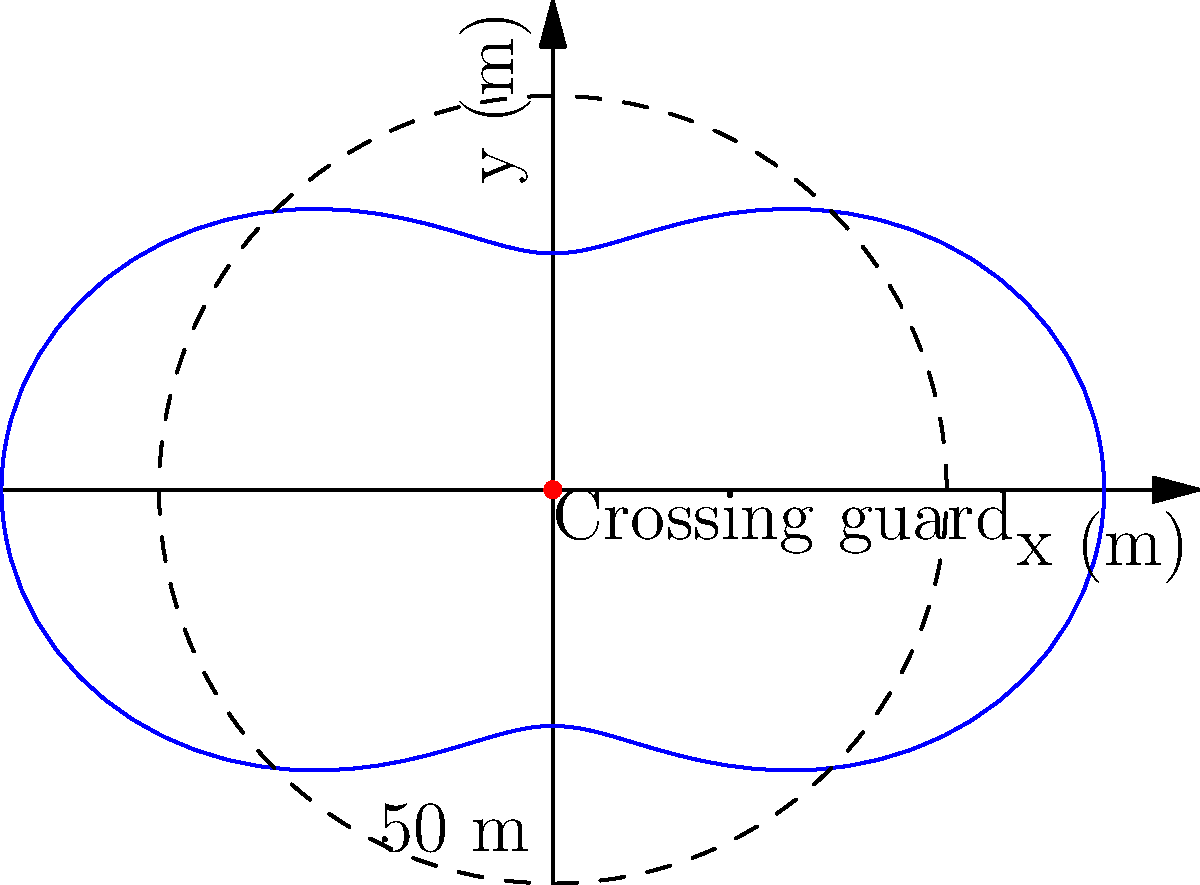A school crossing guard wears a reflective vest with varying visibility depending on the angle. The visibility range can be modeled by the polar equation $r = 50 + 20\cos(2\theta)$, where $r$ is in meters. What is the maximum visibility range of the vest? To find the maximum visibility range, we need to follow these steps:

1) The general form of the equation is $r = 50 + 20\cos(2\theta)$.

2) The maximum value will occur when $\cos(2\theta)$ is at its maximum, which is 1.

3) When $\cos(2\theta) = 1$, the equation becomes:
   $r_{max} = 50 + 20(1)$

4) Simplifying:
   $r_{max} = 50 + 20 = 70$

Therefore, the maximum visibility range of the vest is 70 meters.
Answer: 70 meters 